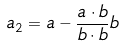Convert formula to latex. <formula><loc_0><loc_0><loc_500><loc_500>a _ { 2 } = a - \frac { a \cdot b } { b \cdot b } b</formula> 